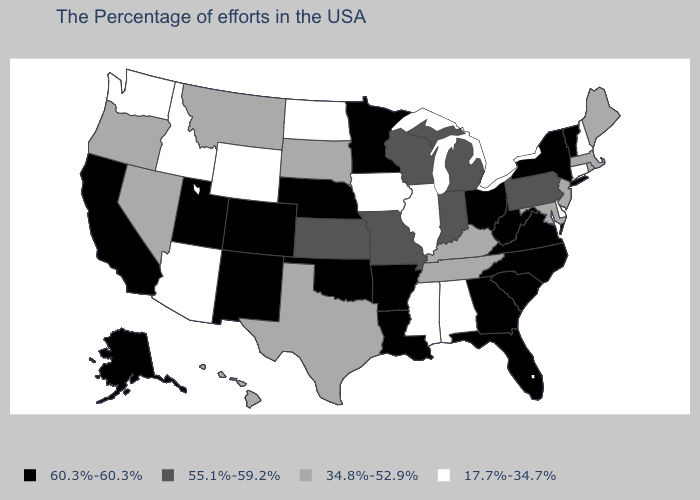How many symbols are there in the legend?
Short answer required. 4. Name the states that have a value in the range 60.3%-60.3%?
Answer briefly. Vermont, New York, Virginia, North Carolina, South Carolina, West Virginia, Ohio, Florida, Georgia, Louisiana, Arkansas, Minnesota, Nebraska, Oklahoma, Colorado, New Mexico, Utah, California, Alaska. Does the first symbol in the legend represent the smallest category?
Keep it brief. No. How many symbols are there in the legend?
Give a very brief answer. 4. What is the value of Delaware?
Write a very short answer. 17.7%-34.7%. What is the value of Idaho?
Quick response, please. 17.7%-34.7%. Name the states that have a value in the range 60.3%-60.3%?
Keep it brief. Vermont, New York, Virginia, North Carolina, South Carolina, West Virginia, Ohio, Florida, Georgia, Louisiana, Arkansas, Minnesota, Nebraska, Oklahoma, Colorado, New Mexico, Utah, California, Alaska. What is the lowest value in states that border Vermont?
Short answer required. 17.7%-34.7%. What is the value of Nevada?
Answer briefly. 34.8%-52.9%. Among the states that border Iowa , does Illinois have the highest value?
Give a very brief answer. No. Which states hav the highest value in the South?
Be succinct. Virginia, North Carolina, South Carolina, West Virginia, Florida, Georgia, Louisiana, Arkansas, Oklahoma. What is the value of Nevada?
Give a very brief answer. 34.8%-52.9%. What is the value of Nebraska?
Write a very short answer. 60.3%-60.3%. What is the lowest value in the USA?
Answer briefly. 17.7%-34.7%. Does Colorado have the same value as Alabama?
Give a very brief answer. No. 